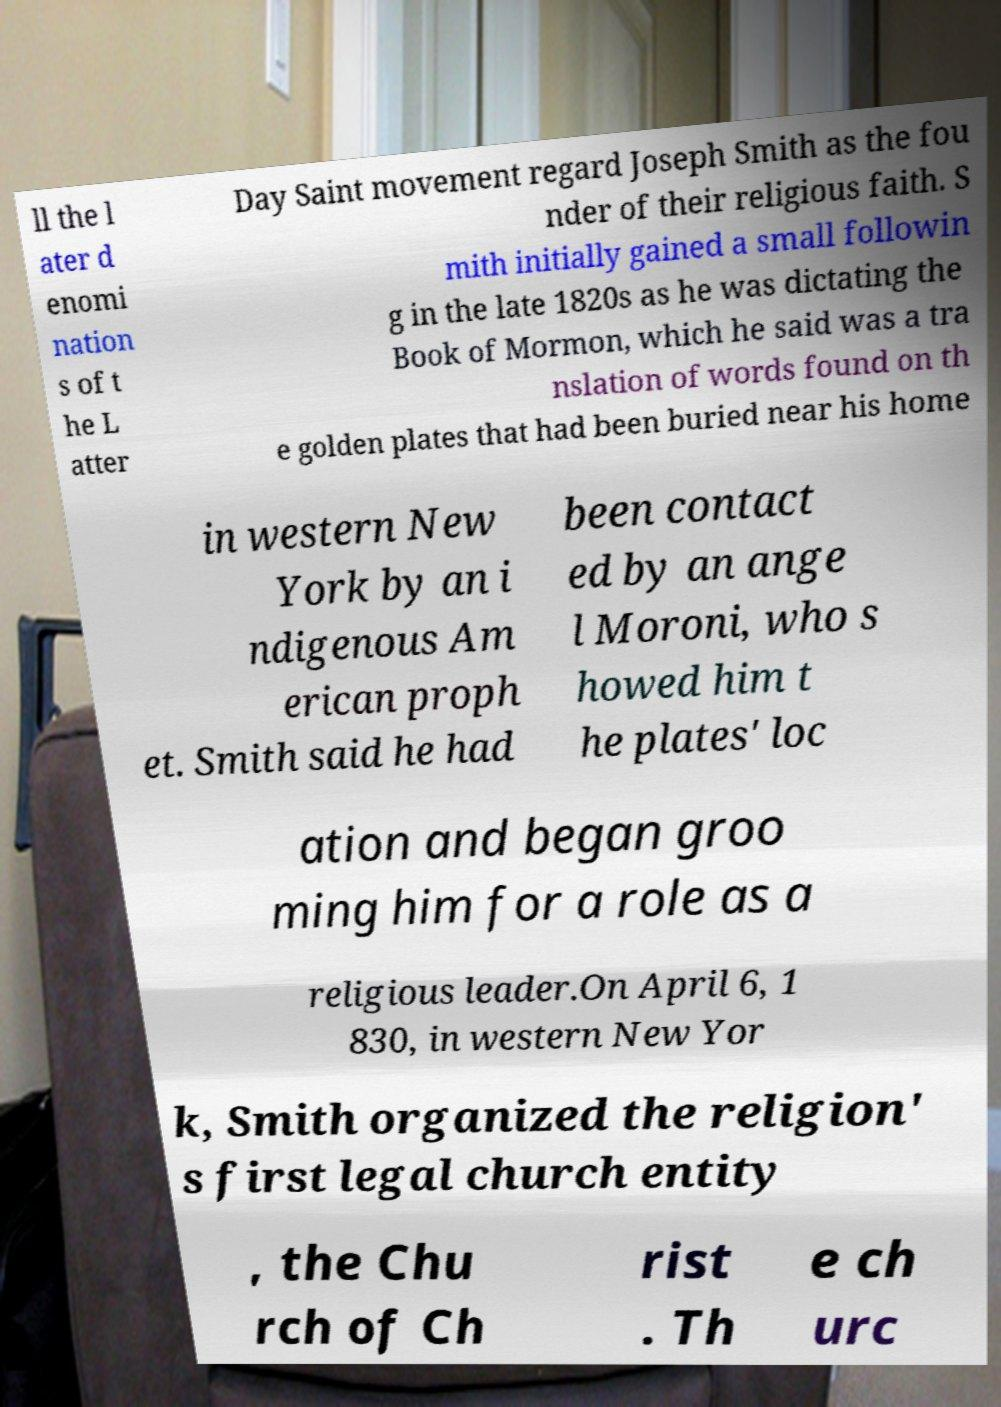Please read and relay the text visible in this image. What does it say? ll the l ater d enomi nation s of t he L atter Day Saint movement regard Joseph Smith as the fou nder of their religious faith. S mith initially gained a small followin g in the late 1820s as he was dictating the Book of Mormon, which he said was a tra nslation of words found on th e golden plates that had been buried near his home in western New York by an i ndigenous Am erican proph et. Smith said he had been contact ed by an ange l Moroni, who s howed him t he plates' loc ation and began groo ming him for a role as a religious leader.On April 6, 1 830, in western New Yor k, Smith organized the religion' s first legal church entity , the Chu rch of Ch rist . Th e ch urc 